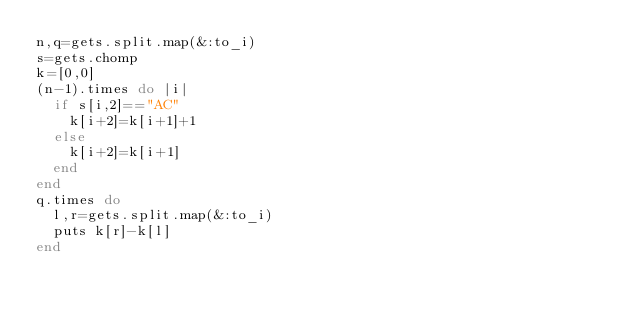<code> <loc_0><loc_0><loc_500><loc_500><_Ruby_>n,q=gets.split.map(&:to_i)
s=gets.chomp
k=[0,0]
(n-1).times do |i|
  if s[i,2]=="AC"
    k[i+2]=k[i+1]+1
  else
    k[i+2]=k[i+1]
  end
end
q.times do
  l,r=gets.split.map(&:to_i)
  puts k[r]-k[l]
end
</code> 